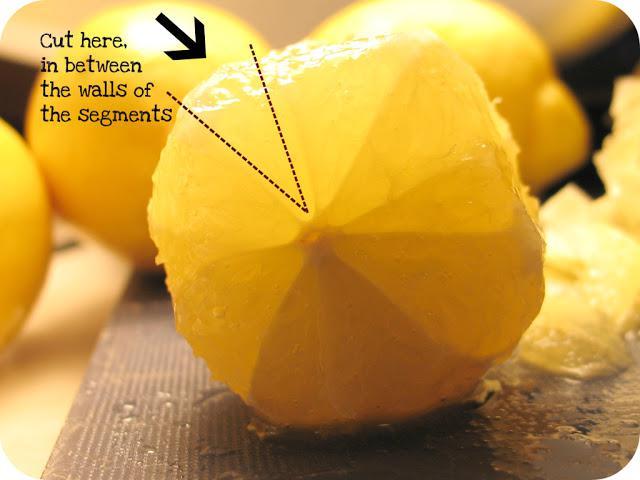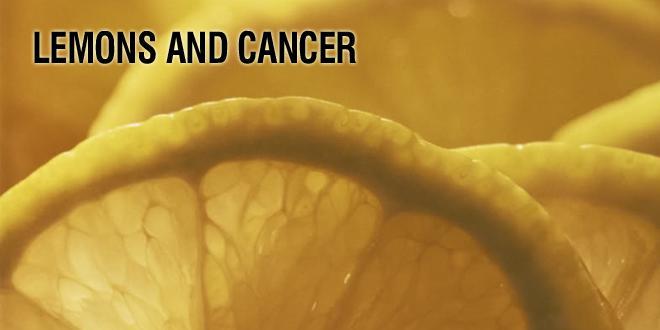The first image is the image on the left, the second image is the image on the right. For the images displayed, is the sentence "There are only whole lemons in one of the images." factually correct? Answer yes or no. No. The first image is the image on the left, the second image is the image on the right. Evaluate the accuracy of this statement regarding the images: "The combined images include cut and whole lemons and a clear glass containing citrus juice.". Is it true? Answer yes or no. No. 